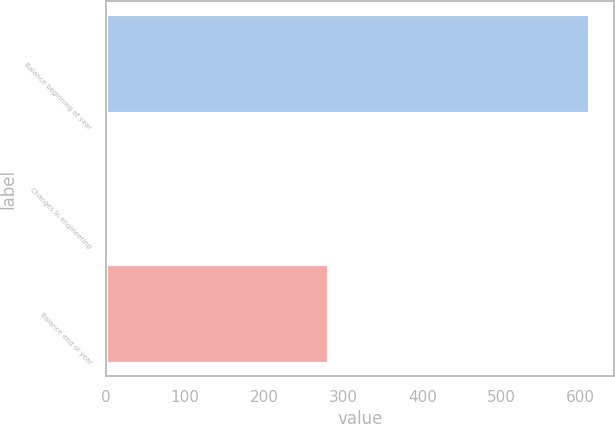<chart> <loc_0><loc_0><loc_500><loc_500><bar_chart><fcel>Balance beginning of year<fcel>Changes in engineering<fcel>Balance end of year<nl><fcel>612<fcel>1<fcel>282<nl></chart> 